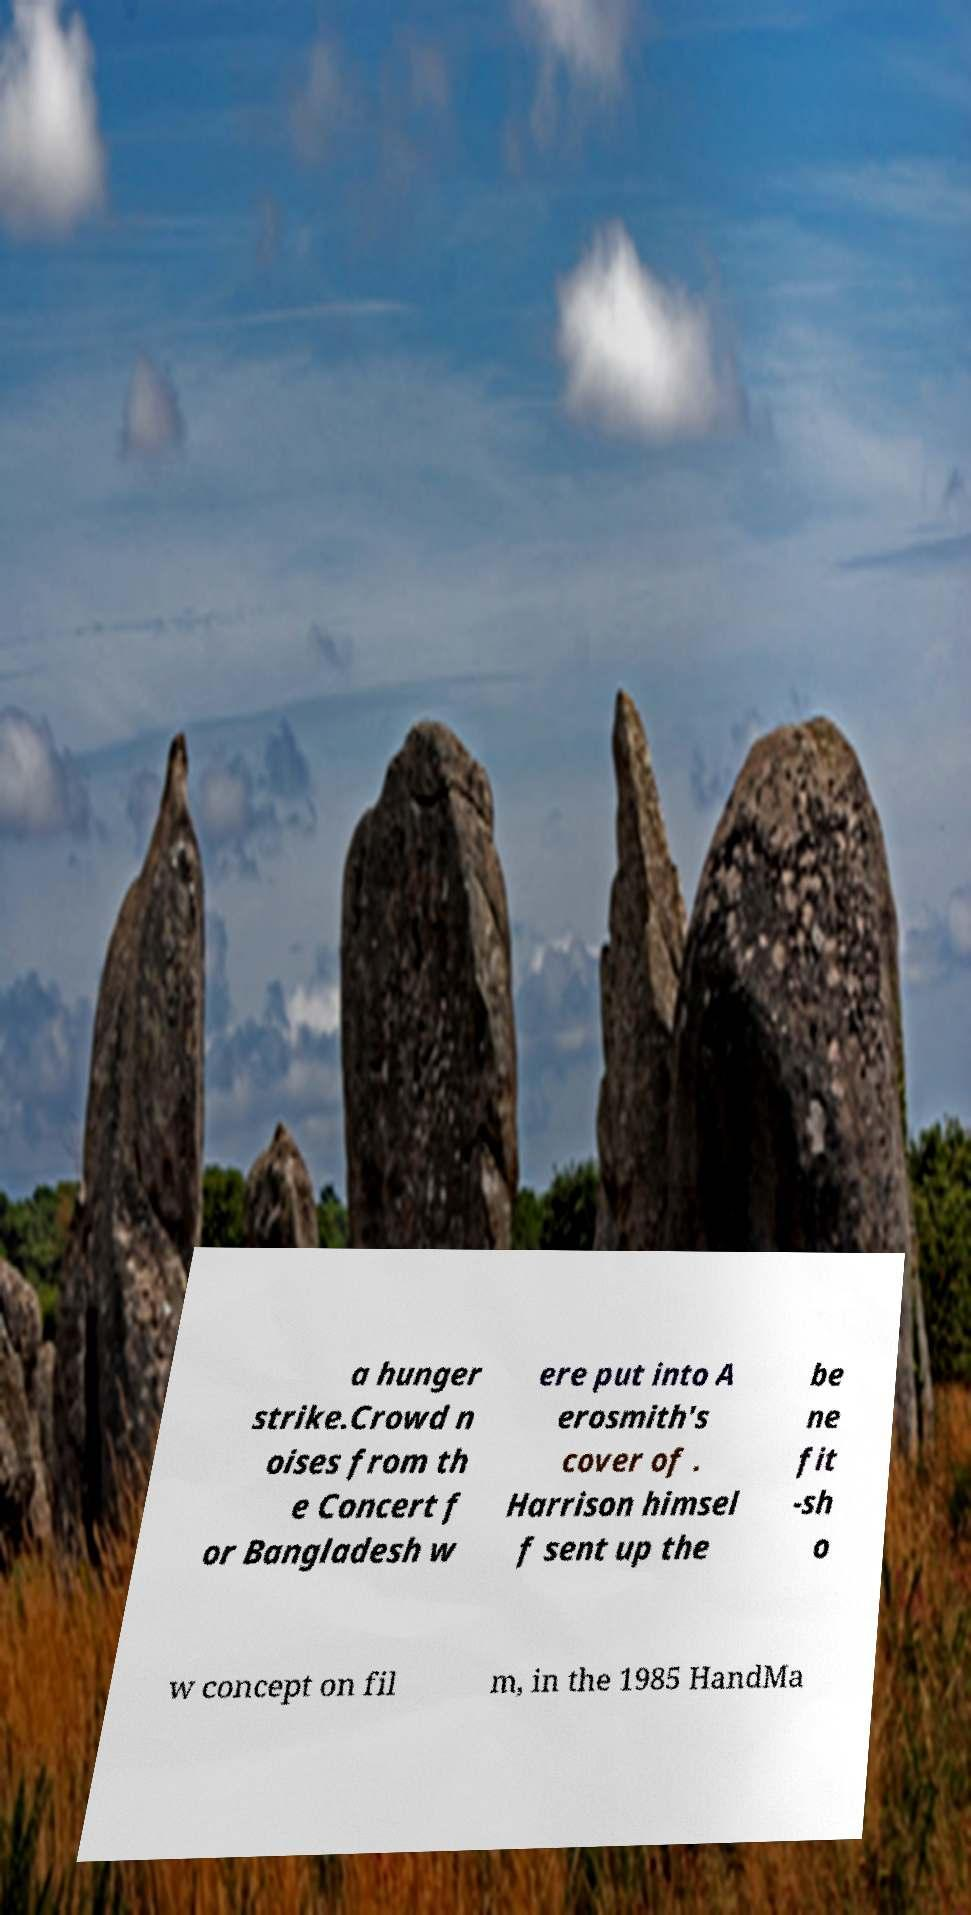Please read and relay the text visible in this image. What does it say? a hunger strike.Crowd n oises from th e Concert f or Bangladesh w ere put into A erosmith's cover of . Harrison himsel f sent up the be ne fit -sh o w concept on fil m, in the 1985 HandMa 